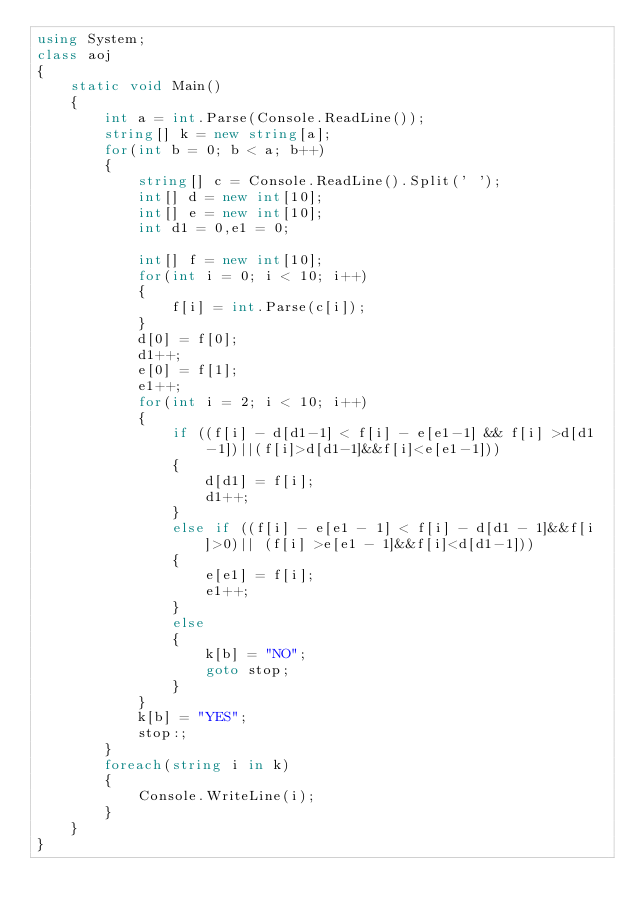Convert code to text. <code><loc_0><loc_0><loc_500><loc_500><_C#_>using System;
class aoj
{
    static void Main()
    {
        int a = int.Parse(Console.ReadLine());
        string[] k = new string[a];
        for(int b = 0; b < a; b++)
        {
            string[] c = Console.ReadLine().Split(' ');
            int[] d = new int[10];
            int[] e = new int[10];
            int d1 = 0,e1 = 0;

            int[] f = new int[10];
            for(int i = 0; i < 10; i++)
            {
                f[i] = int.Parse(c[i]);
            }
            d[0] = f[0];
            d1++;
            e[0] = f[1];
            e1++;
            for(int i = 2; i < 10; i++)
            {
                if ((f[i] - d[d1-1] < f[i] - e[e1-1] && f[i] >d[d1-1])||(f[i]>d[d1-1]&&f[i]<e[e1-1]))
                {
                    d[d1] = f[i];
                    d1++;
                }
                else if ((f[i] - e[e1 - 1] < f[i] - d[d1 - 1]&&f[i]>0)|| (f[i] >e[e1 - 1]&&f[i]<d[d1-1]))
                {
                    e[e1] = f[i];
                    e1++;
                }
                else
                {
                    k[b] = "NO";
                    goto stop;
                }
            }
            k[b] = "YES";
            stop:;
        }
        foreach(string i in k)
        {
            Console.WriteLine(i);
        }
    }	
}</code> 